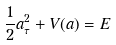Convert formula to latex. <formula><loc_0><loc_0><loc_500><loc_500>\frac { 1 } { 2 } a _ { \tau } ^ { 2 } + V ( a ) = E</formula> 